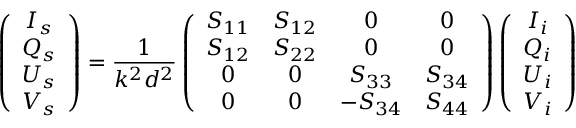Convert formula to latex. <formula><loc_0><loc_0><loc_500><loc_500>\left ( \begin{array} { c c c c } { I _ { s } } \\ { Q _ { s } } \\ { U _ { s } } \\ { V _ { s } } \end{array} \right ) = \frac { 1 } { k ^ { 2 } d ^ { 2 } } \left ( \begin{array} { c c c c } { S _ { 1 1 } } & { S _ { 1 2 } } & { 0 } & { 0 } \\ { S _ { 1 2 } } & { S _ { 2 2 } } & { 0 } & { 0 } \\ { 0 } & { 0 } & { S _ { 3 3 } } & { S _ { 3 4 } } \\ { 0 } & { 0 } & { - S _ { 3 4 } } & { S _ { 4 4 } } \end{array} \right ) \left ( \begin{array} { c c c c } { I _ { i } } \\ { Q _ { i } } \\ { U _ { i } } \\ { V _ { i } } \end{array} \right )</formula> 